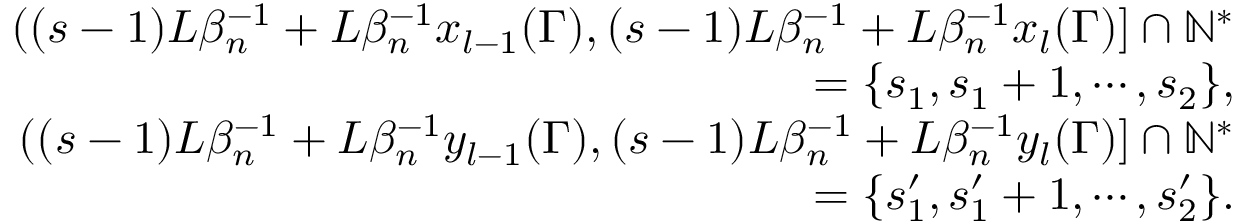<formula> <loc_0><loc_0><loc_500><loc_500>\begin{array} { r l r } & { ( ( s - 1 ) L \beta _ { n } ^ { - 1 } + L \beta _ { n } ^ { - 1 } x _ { l - 1 } ( \Gamma ) , ( s - 1 ) L \beta _ { n } ^ { - 1 } + L \beta _ { n } ^ { - 1 } x _ { l } ( \Gamma ) ] \cap \mathbb { N } ^ { * } } \\ & { = \{ s _ { 1 } , s _ { 1 } + 1 , \cdots , s _ { 2 } \} , } \\ & { ( ( s - 1 ) L \beta _ { n } ^ { - 1 } + L \beta _ { n } ^ { - 1 } y _ { l - 1 } ( \Gamma ) , ( s - 1 ) L \beta _ { n } ^ { - 1 } + L \beta _ { n } ^ { - 1 } y _ { l } ( \Gamma ) ] \cap \mathbb { N } ^ { * } } \\ & { = \{ s _ { 1 } ^ { \prime } , s _ { 1 } ^ { \prime } + 1 , \cdots , s _ { 2 } ^ { \prime } \} . } \end{array}</formula> 